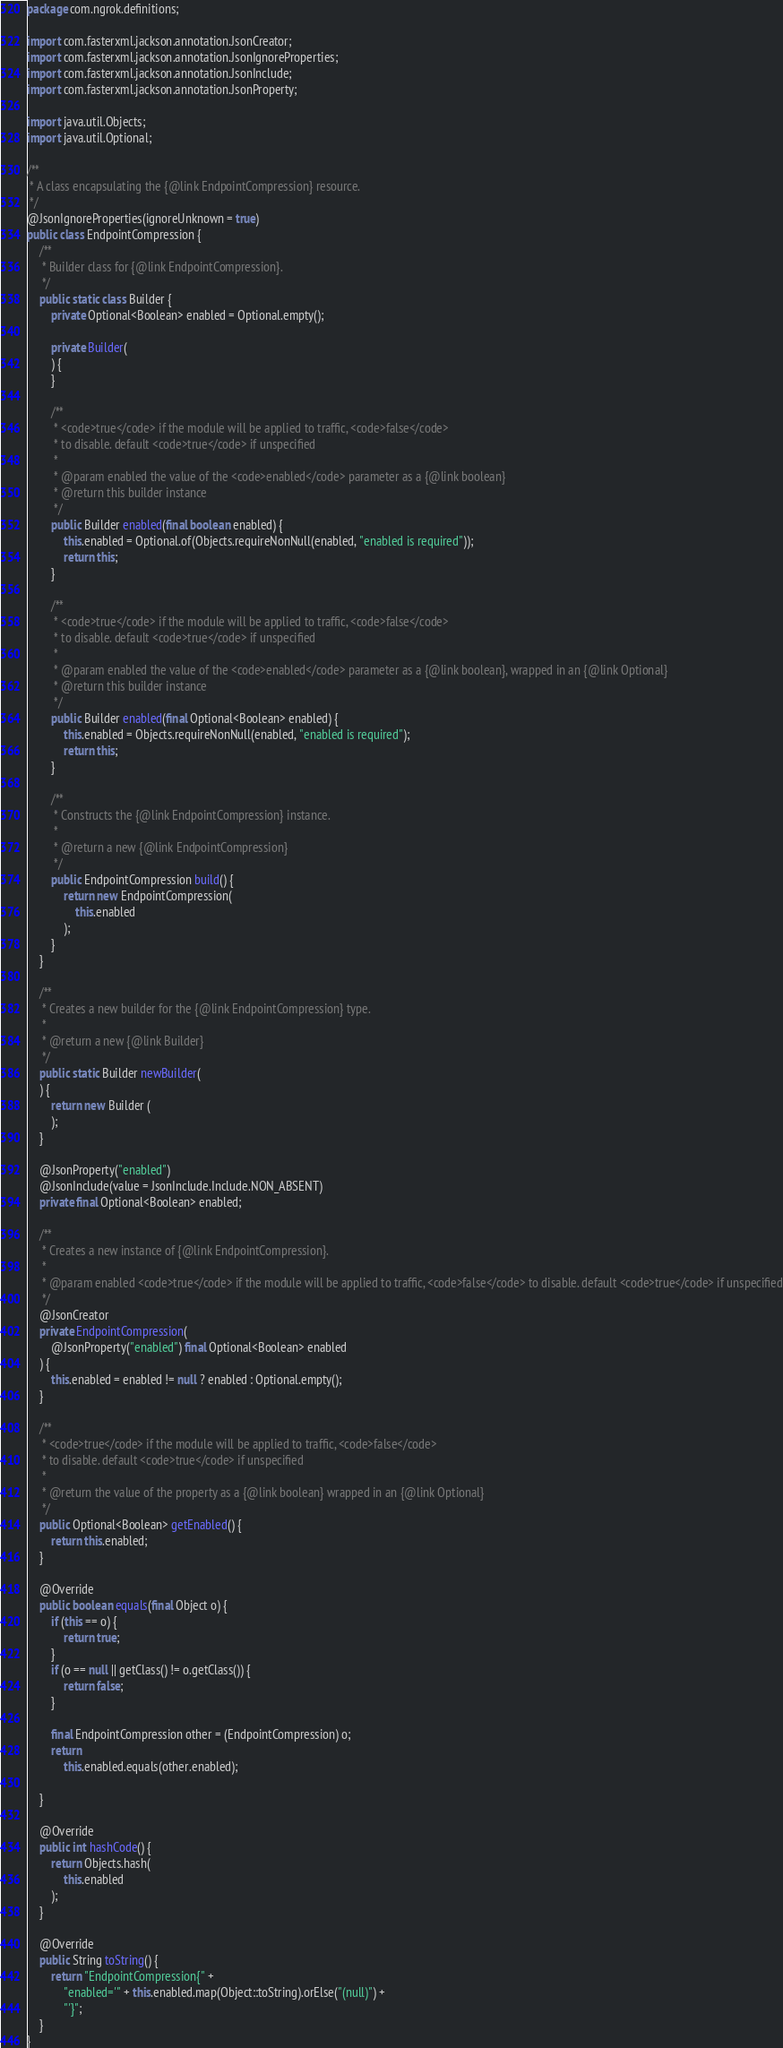Convert code to text. <code><loc_0><loc_0><loc_500><loc_500><_Java_>package com.ngrok.definitions;

import com.fasterxml.jackson.annotation.JsonCreator;
import com.fasterxml.jackson.annotation.JsonIgnoreProperties;
import com.fasterxml.jackson.annotation.JsonInclude;
import com.fasterxml.jackson.annotation.JsonProperty;

import java.util.Objects;
import java.util.Optional;

/**
 * A class encapsulating the {@link EndpointCompression} resource.
 */
@JsonIgnoreProperties(ignoreUnknown = true)
public class EndpointCompression {
    /**
     * Builder class for {@link EndpointCompression}.
     */
    public static class Builder {
        private Optional<Boolean> enabled = Optional.empty();

        private Builder(
        ) {
        }

        /**
         * <code>true</code> if the module will be applied to traffic, <code>false</code>
         * to disable. default <code>true</code> if unspecified
		 *
		 * @param enabled the value of the <code>enabled</code> parameter as a {@link boolean}
		 * @return this builder instance
		 */
        public Builder enabled(final boolean enabled) {
            this.enabled = Optional.of(Objects.requireNonNull(enabled, "enabled is required"));
            return this;
        }

        /**
         * <code>true</code> if the module will be applied to traffic, <code>false</code>
         * to disable. default <code>true</code> if unspecified
		 *
		 * @param enabled the value of the <code>enabled</code> parameter as a {@link boolean}, wrapped in an {@link Optional}
		 * @return this builder instance
		 */
        public Builder enabled(final Optional<Boolean> enabled) {
            this.enabled = Objects.requireNonNull(enabled, "enabled is required");
            return this;
        }

        /**
         * Constructs the {@link EndpointCompression} instance.
         *
         * @return a new {@link EndpointCompression}
         */
        public EndpointCompression build() {
            return new EndpointCompression(
                this.enabled
            );
        }
    }

    /**
     * Creates a new builder for the {@link EndpointCompression} type.
     *
     * @return a new {@link Builder}
     */
    public static Builder newBuilder(
    ) {
        return new Builder (
        );
    }

    @JsonProperty("enabled")
    @JsonInclude(value = JsonInclude.Include.NON_ABSENT)
    private final Optional<Boolean> enabled;

    /**
     * Creates a new instance of {@link EndpointCompression}.
     *
     * @param enabled <code>true</code> if the module will be applied to traffic, <code>false</code> to disable. default <code>true</code> if unspecified
     */
    @JsonCreator
    private EndpointCompression(
        @JsonProperty("enabled") final Optional<Boolean> enabled
    ) {
        this.enabled = enabled != null ? enabled : Optional.empty();
    }

    /**
     * <code>true</code> if the module will be applied to traffic, <code>false</code>
     * to disable. default <code>true</code> if unspecified
     *
     * @return the value of the property as a {@link boolean} wrapped in an {@link Optional}
     */
    public Optional<Boolean> getEnabled() {
        return this.enabled;
    }

    @Override
    public boolean equals(final Object o) {
        if (this == o) {
            return true;
        }
        if (o == null || getClass() != o.getClass()) {
            return false;
        }
        
        final EndpointCompression other = (EndpointCompression) o;
        return
            this.enabled.equals(other.enabled);
        
    }

    @Override
    public int hashCode() {
        return Objects.hash(
            this.enabled
        );
    }

    @Override
    public String toString() {
        return "EndpointCompression{" +
            "enabled='" + this.enabled.map(Object::toString).orElse("(null)") +
            "'}";
    }
}
</code> 